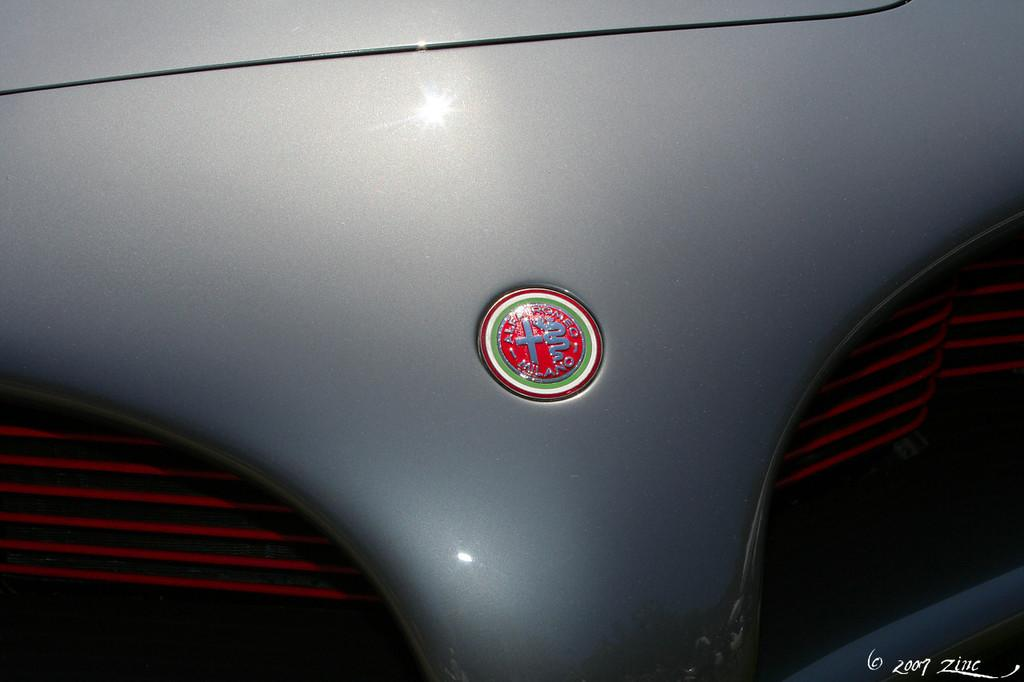What is the main subject of the image? The main subject of the image is a vehicle. Can you describe the view of the vehicle in the image? The view of the vehicle is from the front. What attempt was made to destroy the vehicle in the image? There is no indication in the image that any attempt was made to destroy the vehicle. What station is the vehicle parked at in the image? There is no reference to a station or any indication that the vehicle is parked in the image. 